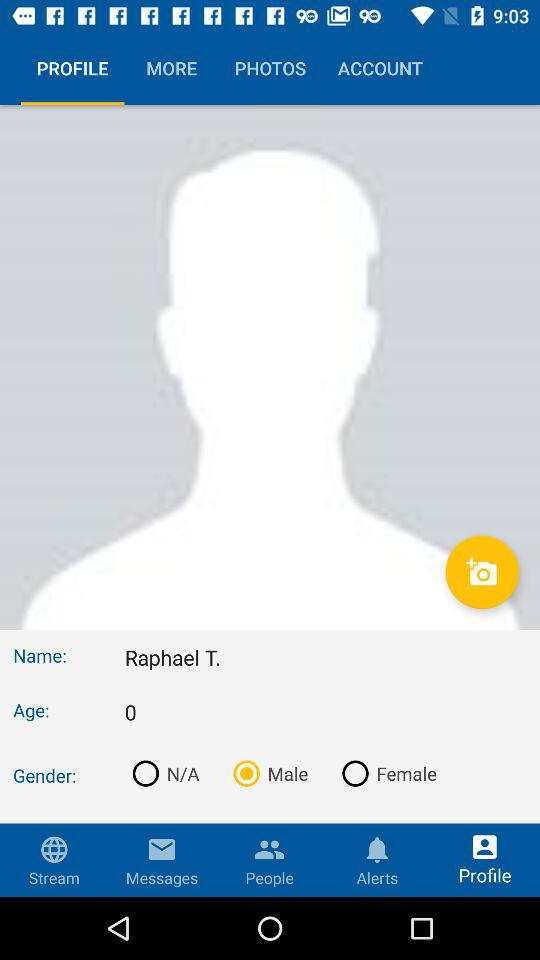What is the selected tab? The selected tab is "PROFILE". 